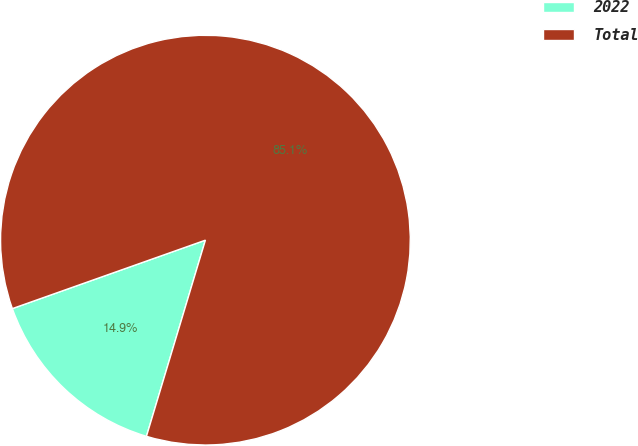<chart> <loc_0><loc_0><loc_500><loc_500><pie_chart><fcel>2022<fcel>Total<nl><fcel>14.93%<fcel>85.07%<nl></chart> 